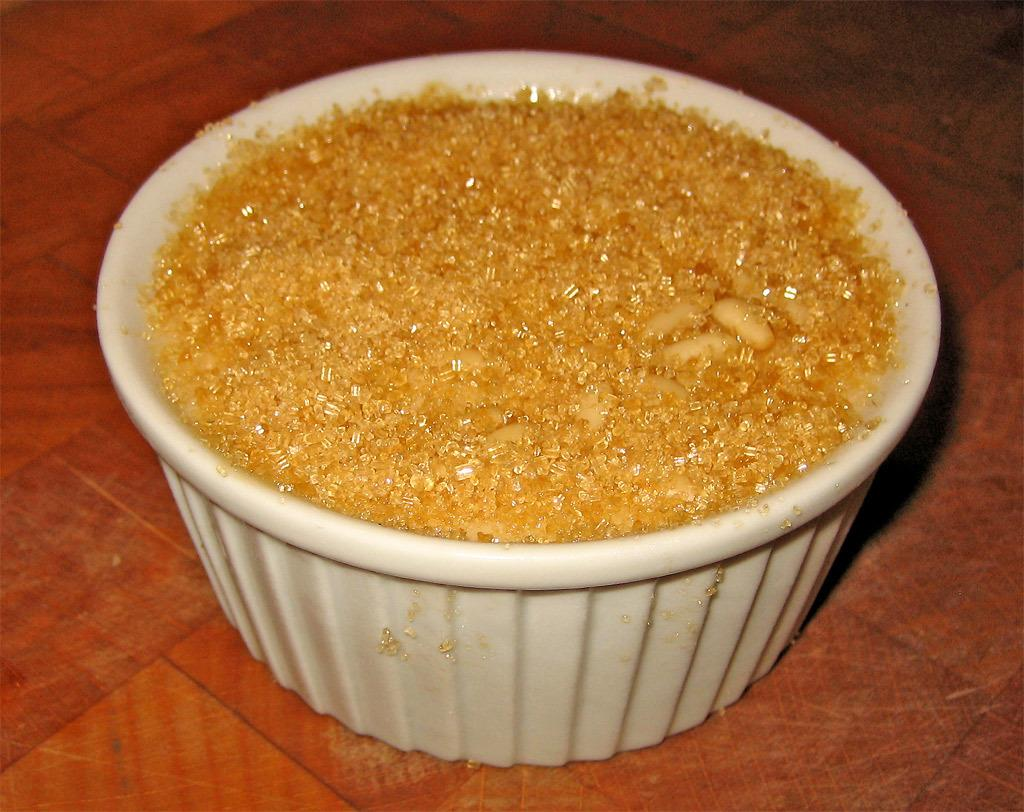What is placed in a bowl in the image? There is an eatable item placed in a bowl in the image. What type of meat is being cooked in the image? There is no meat or cooking activity present in the image; it only shows an eatable item placed in a bowl. 